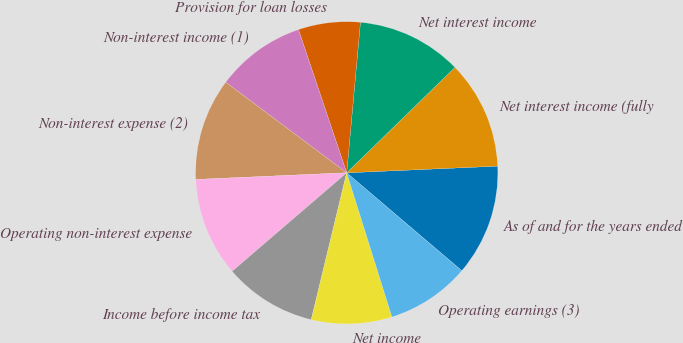Convert chart. <chart><loc_0><loc_0><loc_500><loc_500><pie_chart><fcel>As of and for the years ended<fcel>Net interest income (fully<fcel>Net interest income<fcel>Provision for loan losses<fcel>Non-interest income (1)<fcel>Non-interest expense (2)<fcel>Operating non-interest expense<fcel>Income before income tax<fcel>Net income<fcel>Operating earnings (3)<nl><fcel>11.92%<fcel>11.59%<fcel>11.26%<fcel>6.62%<fcel>9.6%<fcel>10.93%<fcel>10.6%<fcel>9.93%<fcel>8.61%<fcel>8.94%<nl></chart> 